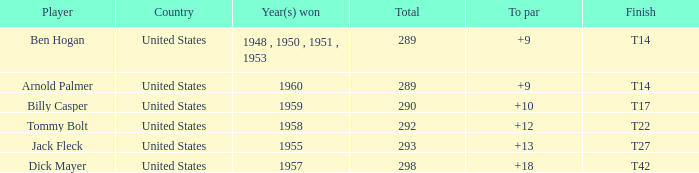What is the total number of Total, when To Par is 12? 1.0. 